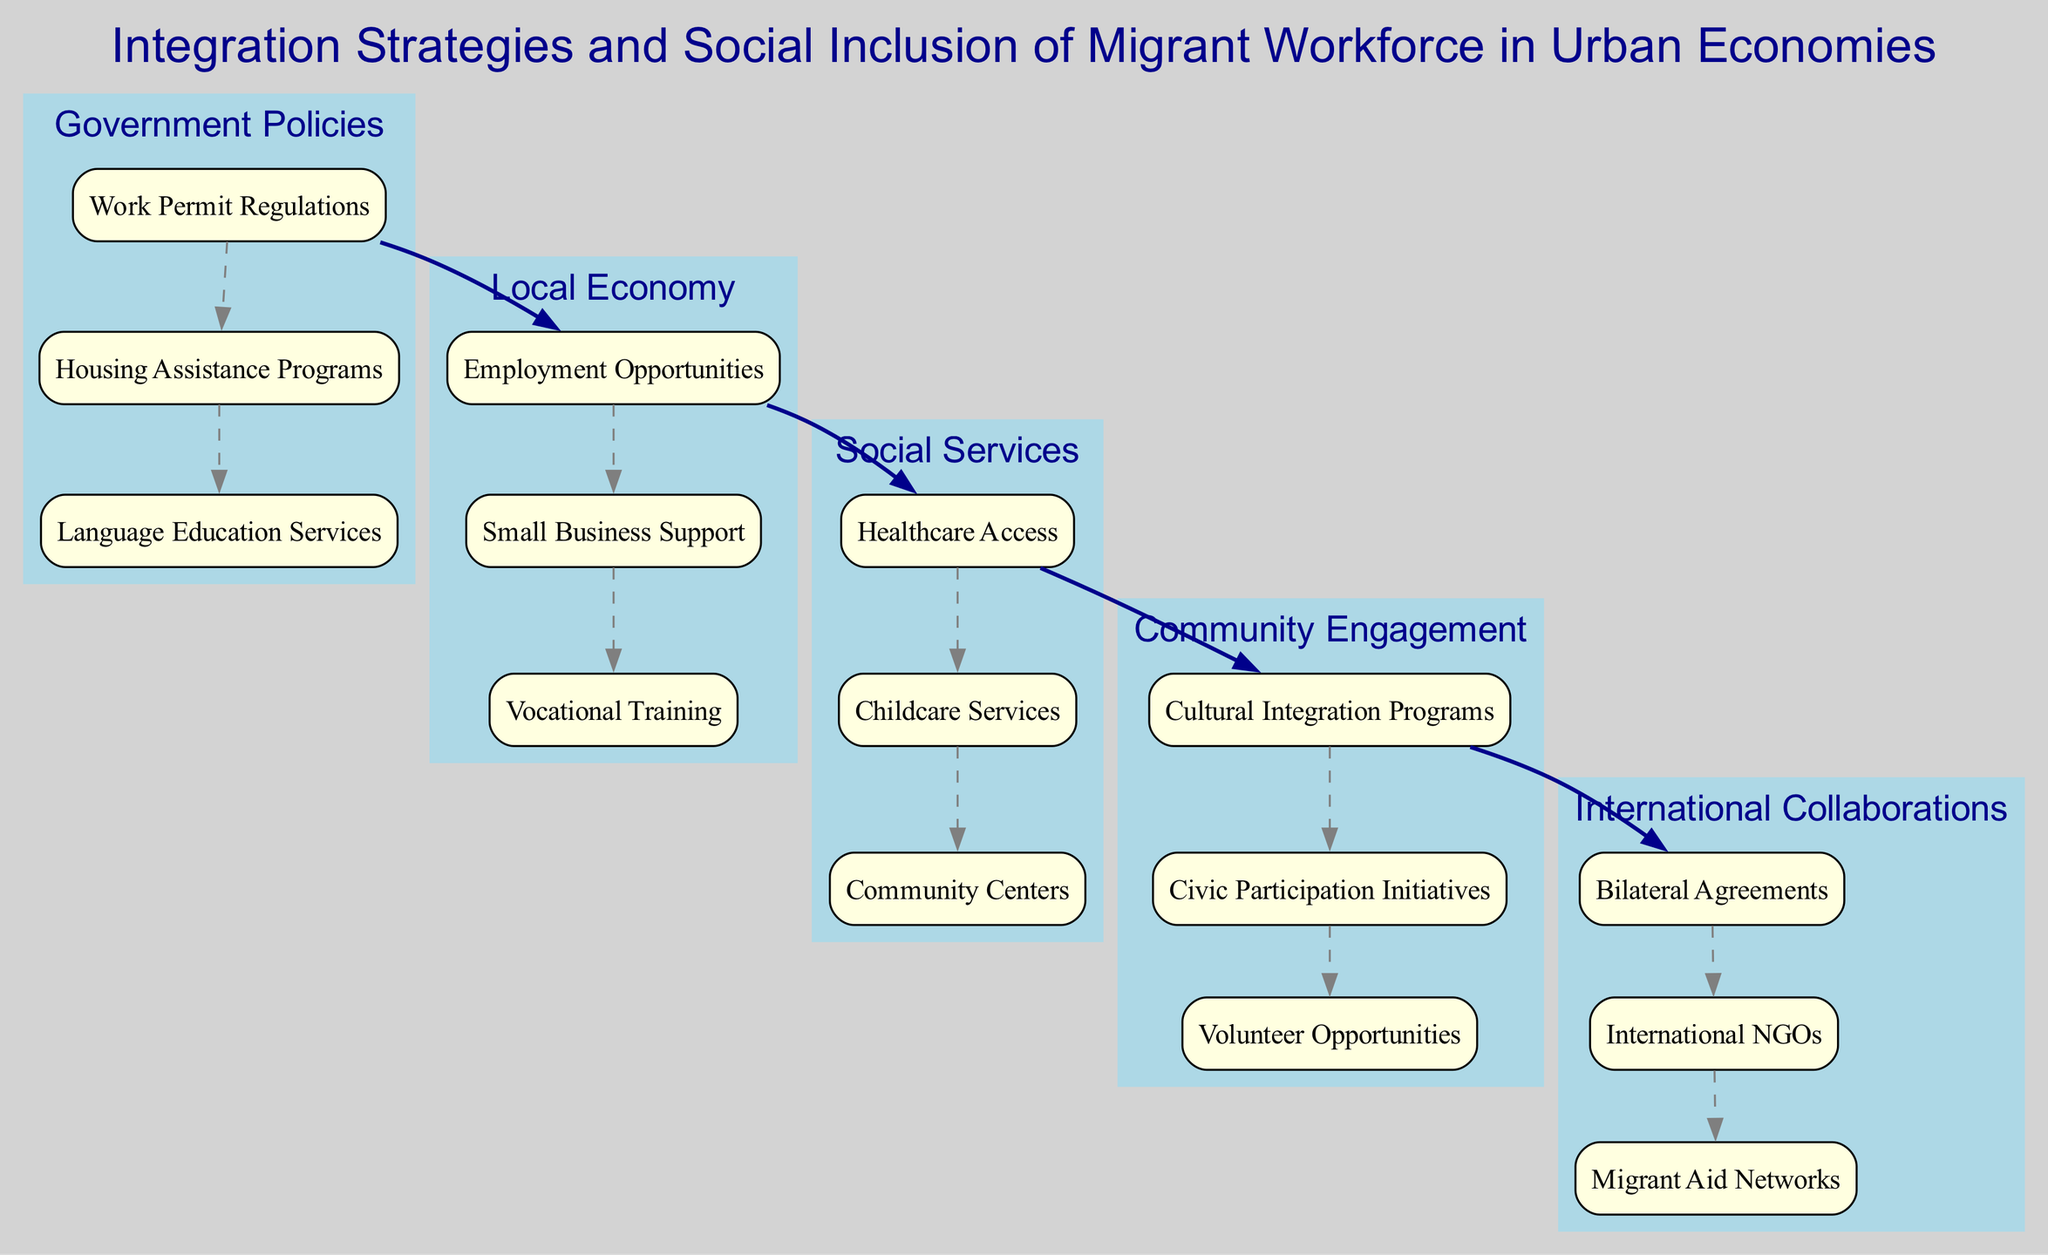What are the three main elements in the diagram? The main elements are "Government Policies", "Local Economy", and "Social Services".
Answer: Government Policies, Local Economy, Social Services How many sub-elements are under "Community Engagement"? Under "Community Engagement", there are three sub-elements: "Cultural Integration Programs", "Civic Participation Initiatives", and "Volunteer Opportunities".
Answer: 3 What is one example of a language education service? "Language Education Services" is the sub-element within "Government Policies", which specifically addresses the need for language skills among migrants.
Answer: Language Education Services What links "International Collaborations" to "Government Policies"? The connection is represented through the sub-elements of both elements; for example, "Bilateral Agreements" under "International Collaborations" can relate to "Work Permit Regulations" under "Government Policies".
Answer: Bilateral Agreements to Work Permit Regulations What type of program is "Healthcare Access"? "Healthcare Access" is categorized under "Social Services", indicating the need for healthcare support for the migrant workforce.
Answer: Social Services Which element contains "Small Business Support"? "Small Business Support" is a sub-element under "Local Economy", highlighting the economic integration aspect for migrants.
Answer: Local Economy How many elements are directly linked to "Community Engagement"? "Community Engagement" is linked to three elements, including "Cultural Integration Programs", "Civic Participation Initiatives", and "Volunteer Opportunities". Therefore, it indicates rich opportunities for integrating migrants at a community level.
Answer: 3 What is the role of "International NGOs" in integration? "International NGOs" serve as part of "International Collaborations", which can provide resources and support to develop and implement integration strategies for migrant populations.
Answer: International Collaborations What is the primary focus of "Housing Assistance Programs"? "Housing Assistance Programs" is aimed at providing housing resources to migrants, constituting a critical part of the integration process under "Government Policies".
Answer: Housing Assistance Programs 